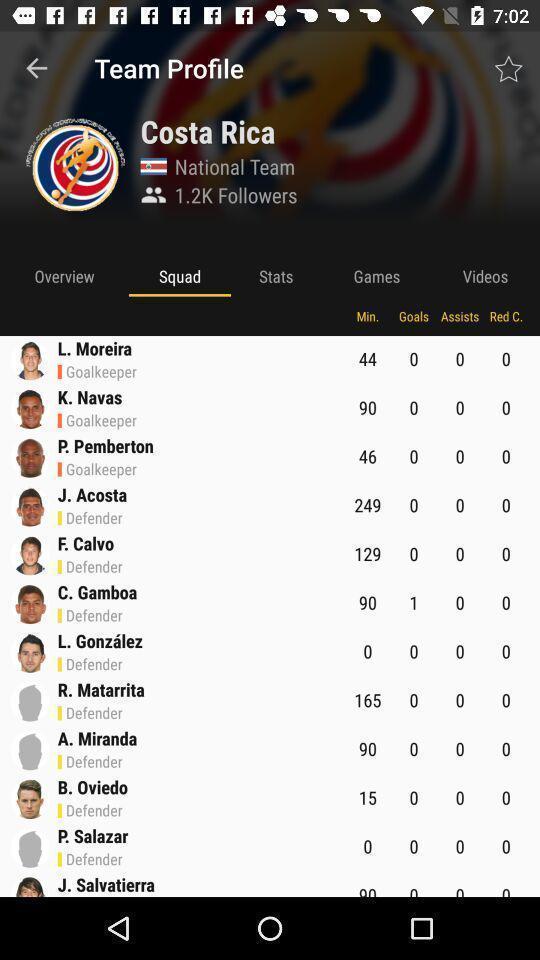Tell me what you see in this picture. Screen displaying a list of players in a sports application. 